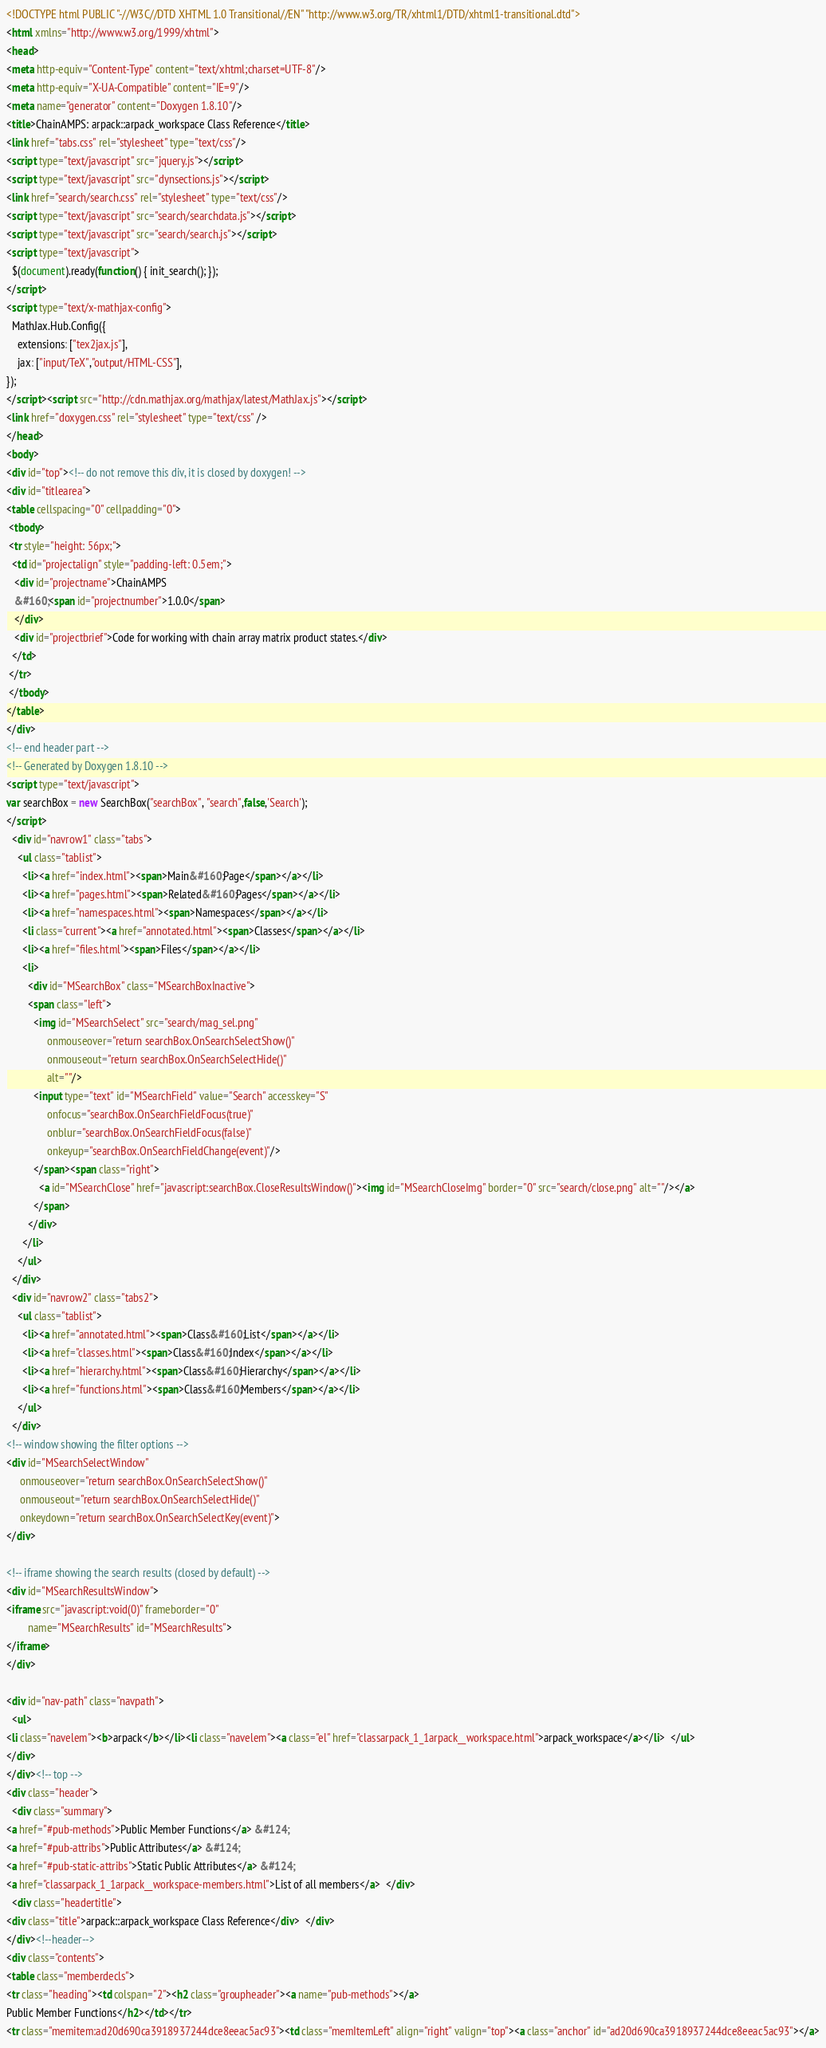Convert code to text. <code><loc_0><loc_0><loc_500><loc_500><_HTML_><!DOCTYPE html PUBLIC "-//W3C//DTD XHTML 1.0 Transitional//EN" "http://www.w3.org/TR/xhtml1/DTD/xhtml1-transitional.dtd">
<html xmlns="http://www.w3.org/1999/xhtml">
<head>
<meta http-equiv="Content-Type" content="text/xhtml;charset=UTF-8"/>
<meta http-equiv="X-UA-Compatible" content="IE=9"/>
<meta name="generator" content="Doxygen 1.8.10"/>
<title>ChainAMPS: arpack::arpack_workspace Class Reference</title>
<link href="tabs.css" rel="stylesheet" type="text/css"/>
<script type="text/javascript" src="jquery.js"></script>
<script type="text/javascript" src="dynsections.js"></script>
<link href="search/search.css" rel="stylesheet" type="text/css"/>
<script type="text/javascript" src="search/searchdata.js"></script>
<script type="text/javascript" src="search/search.js"></script>
<script type="text/javascript">
  $(document).ready(function() { init_search(); });
</script>
<script type="text/x-mathjax-config">
  MathJax.Hub.Config({
    extensions: ["tex2jax.js"],
    jax: ["input/TeX","output/HTML-CSS"],
});
</script><script src="http://cdn.mathjax.org/mathjax/latest/MathJax.js"></script>
<link href="doxygen.css" rel="stylesheet" type="text/css" />
</head>
<body>
<div id="top"><!-- do not remove this div, it is closed by doxygen! -->
<div id="titlearea">
<table cellspacing="0" cellpadding="0">
 <tbody>
 <tr style="height: 56px;">
  <td id="projectalign" style="padding-left: 0.5em;">
   <div id="projectname">ChainAMPS
   &#160;<span id="projectnumber">1.0.0</span>
   </div>
   <div id="projectbrief">Code for working with chain array matrix product states.</div>
  </td>
 </tr>
 </tbody>
</table>
</div>
<!-- end header part -->
<!-- Generated by Doxygen 1.8.10 -->
<script type="text/javascript">
var searchBox = new SearchBox("searchBox", "search",false,'Search');
</script>
  <div id="navrow1" class="tabs">
    <ul class="tablist">
      <li><a href="index.html"><span>Main&#160;Page</span></a></li>
      <li><a href="pages.html"><span>Related&#160;Pages</span></a></li>
      <li><a href="namespaces.html"><span>Namespaces</span></a></li>
      <li class="current"><a href="annotated.html"><span>Classes</span></a></li>
      <li><a href="files.html"><span>Files</span></a></li>
      <li>
        <div id="MSearchBox" class="MSearchBoxInactive">
        <span class="left">
          <img id="MSearchSelect" src="search/mag_sel.png"
               onmouseover="return searchBox.OnSearchSelectShow()"
               onmouseout="return searchBox.OnSearchSelectHide()"
               alt=""/>
          <input type="text" id="MSearchField" value="Search" accesskey="S"
               onfocus="searchBox.OnSearchFieldFocus(true)" 
               onblur="searchBox.OnSearchFieldFocus(false)" 
               onkeyup="searchBox.OnSearchFieldChange(event)"/>
          </span><span class="right">
            <a id="MSearchClose" href="javascript:searchBox.CloseResultsWindow()"><img id="MSearchCloseImg" border="0" src="search/close.png" alt=""/></a>
          </span>
        </div>
      </li>
    </ul>
  </div>
  <div id="navrow2" class="tabs2">
    <ul class="tablist">
      <li><a href="annotated.html"><span>Class&#160;List</span></a></li>
      <li><a href="classes.html"><span>Class&#160;Index</span></a></li>
      <li><a href="hierarchy.html"><span>Class&#160;Hierarchy</span></a></li>
      <li><a href="functions.html"><span>Class&#160;Members</span></a></li>
    </ul>
  </div>
<!-- window showing the filter options -->
<div id="MSearchSelectWindow"
     onmouseover="return searchBox.OnSearchSelectShow()"
     onmouseout="return searchBox.OnSearchSelectHide()"
     onkeydown="return searchBox.OnSearchSelectKey(event)">
</div>

<!-- iframe showing the search results (closed by default) -->
<div id="MSearchResultsWindow">
<iframe src="javascript:void(0)" frameborder="0" 
        name="MSearchResults" id="MSearchResults">
</iframe>
</div>

<div id="nav-path" class="navpath">
  <ul>
<li class="navelem"><b>arpack</b></li><li class="navelem"><a class="el" href="classarpack_1_1arpack__workspace.html">arpack_workspace</a></li>  </ul>
</div>
</div><!-- top -->
<div class="header">
  <div class="summary">
<a href="#pub-methods">Public Member Functions</a> &#124;
<a href="#pub-attribs">Public Attributes</a> &#124;
<a href="#pub-static-attribs">Static Public Attributes</a> &#124;
<a href="classarpack_1_1arpack__workspace-members.html">List of all members</a>  </div>
  <div class="headertitle">
<div class="title">arpack::arpack_workspace Class Reference</div>  </div>
</div><!--header-->
<div class="contents">
<table class="memberdecls">
<tr class="heading"><td colspan="2"><h2 class="groupheader"><a name="pub-methods"></a>
Public Member Functions</h2></td></tr>
<tr class="memitem:ad20d690ca3918937244dce8eeac5ac93"><td class="memItemLeft" align="right" valign="top"><a class="anchor" id="ad20d690ca3918937244dce8eeac5ac93"></a></code> 